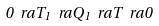Convert formula to latex. <formula><loc_0><loc_0><loc_500><loc_500>0 \ r a T _ { 1 } \ r a Q _ { 1 } \ r a T \ r a 0</formula> 